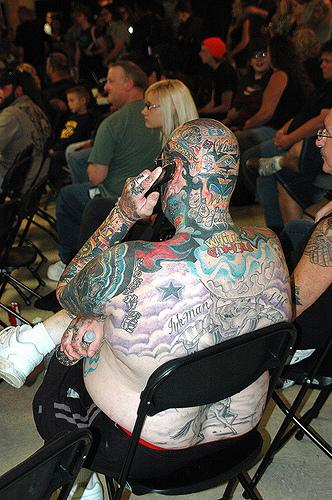Question: what is the man holding?
Choices:
A. A phone.
B. A pencil.
C. A hose.
D. A hat.
Answer with the letter. Answer: A Question: what color is the chair?
Choices:
A. Brown.
B. White.
C. Black.
D. Gold.
Answer with the letter. Answer: C 